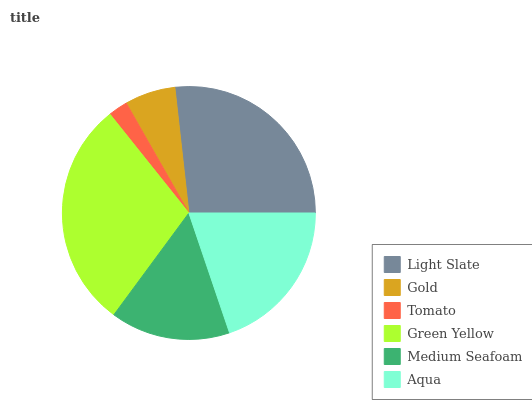Is Tomato the minimum?
Answer yes or no. Yes. Is Green Yellow the maximum?
Answer yes or no. Yes. Is Gold the minimum?
Answer yes or no. No. Is Gold the maximum?
Answer yes or no. No. Is Light Slate greater than Gold?
Answer yes or no. Yes. Is Gold less than Light Slate?
Answer yes or no. Yes. Is Gold greater than Light Slate?
Answer yes or no. No. Is Light Slate less than Gold?
Answer yes or no. No. Is Aqua the high median?
Answer yes or no. Yes. Is Medium Seafoam the low median?
Answer yes or no. Yes. Is Tomato the high median?
Answer yes or no. No. Is Green Yellow the low median?
Answer yes or no. No. 